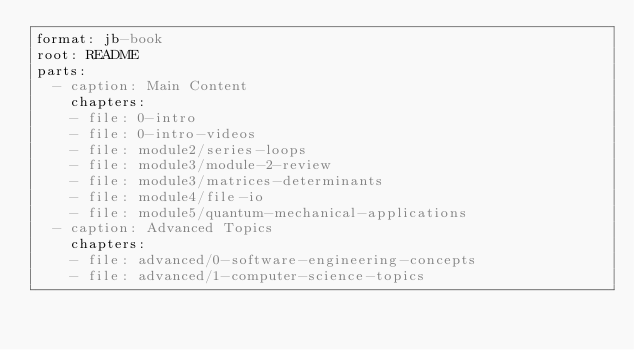<code> <loc_0><loc_0><loc_500><loc_500><_YAML_>format: jb-book
root: README
parts: 
  - caption: Main Content
    chapters:
    - file: 0-intro
    - file: 0-intro-videos
    - file: module2/series-loops
    - file: module3/module-2-review
    - file: module3/matrices-determinants
    - file: module4/file-io
    - file: module5/quantum-mechanical-applications
  - caption: Advanced Topics
    chapters:
    - file: advanced/0-software-engineering-concepts
    - file: advanced/1-computer-science-topics</code> 